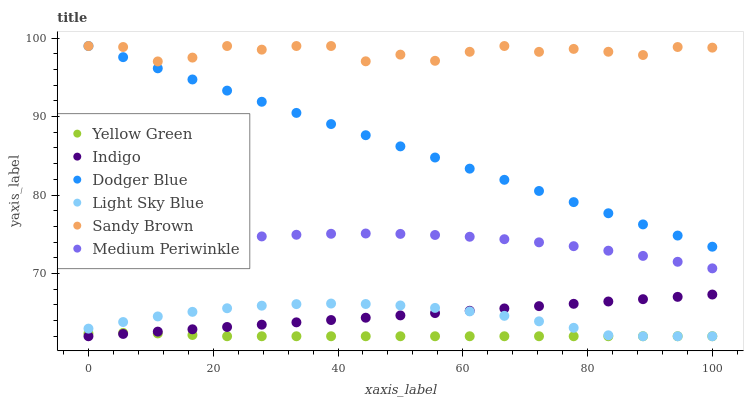Does Yellow Green have the minimum area under the curve?
Answer yes or no. Yes. Does Sandy Brown have the maximum area under the curve?
Answer yes or no. Yes. Does Medium Periwinkle have the minimum area under the curve?
Answer yes or no. No. Does Medium Periwinkle have the maximum area under the curve?
Answer yes or no. No. Is Indigo the smoothest?
Answer yes or no. Yes. Is Sandy Brown the roughest?
Answer yes or no. Yes. Is Yellow Green the smoothest?
Answer yes or no. No. Is Yellow Green the roughest?
Answer yes or no. No. Does Indigo have the lowest value?
Answer yes or no. Yes. Does Medium Periwinkle have the lowest value?
Answer yes or no. No. Does Sandy Brown have the highest value?
Answer yes or no. Yes. Does Medium Periwinkle have the highest value?
Answer yes or no. No. Is Light Sky Blue less than Medium Periwinkle?
Answer yes or no. Yes. Is Sandy Brown greater than Medium Periwinkle?
Answer yes or no. Yes. Does Indigo intersect Light Sky Blue?
Answer yes or no. Yes. Is Indigo less than Light Sky Blue?
Answer yes or no. No. Is Indigo greater than Light Sky Blue?
Answer yes or no. No. Does Light Sky Blue intersect Medium Periwinkle?
Answer yes or no. No. 